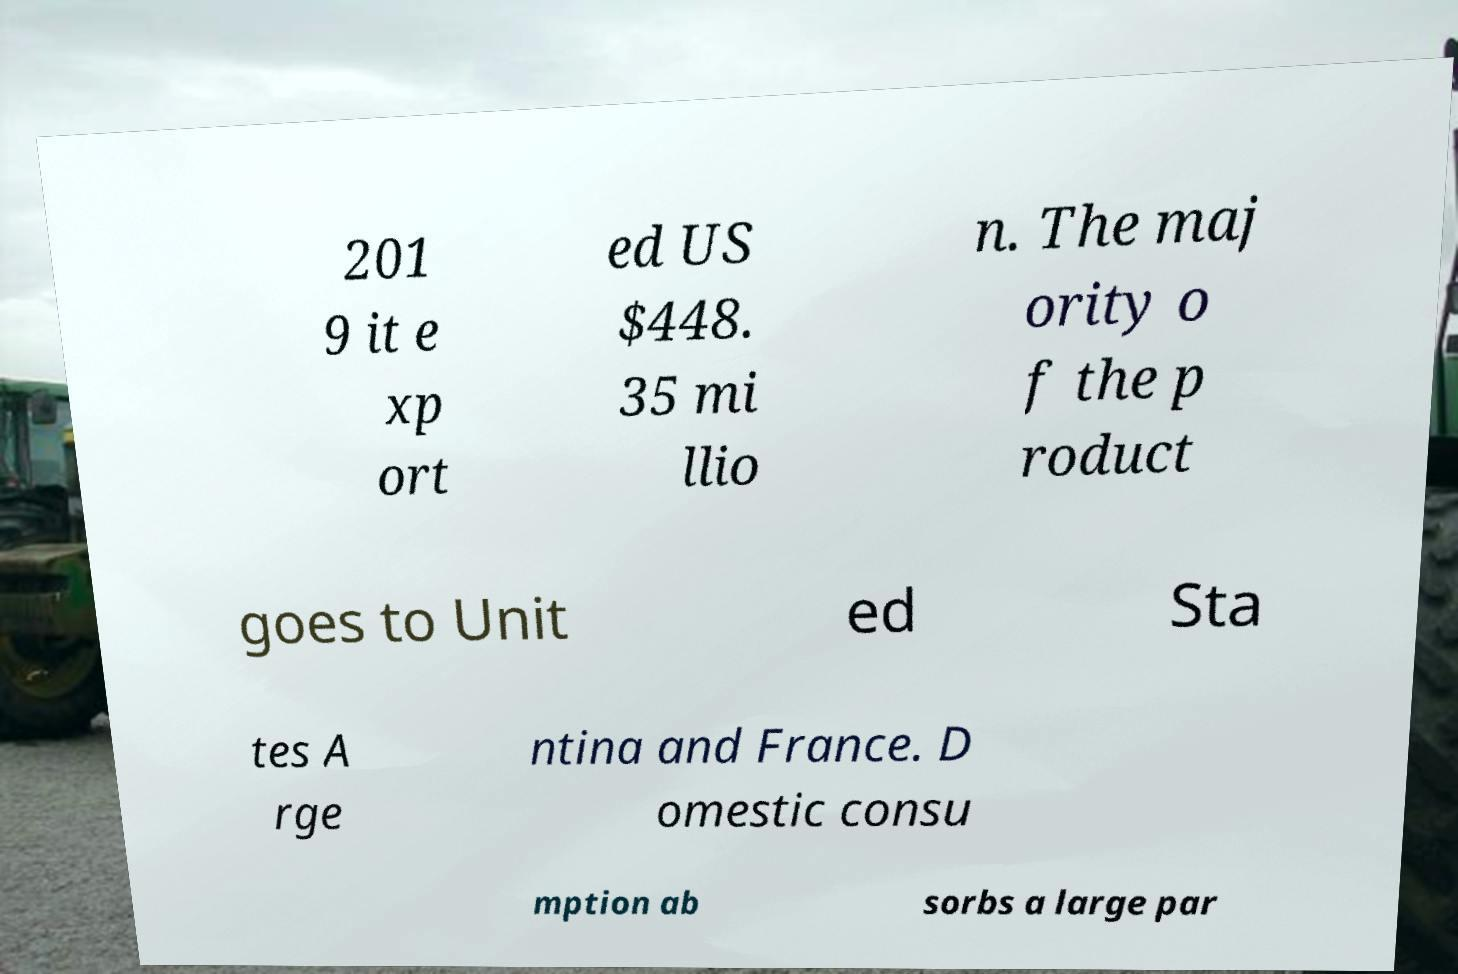For documentation purposes, I need the text within this image transcribed. Could you provide that? 201 9 it e xp ort ed US $448. 35 mi llio n. The maj ority o f the p roduct goes to Unit ed Sta tes A rge ntina and France. D omestic consu mption ab sorbs a large par 